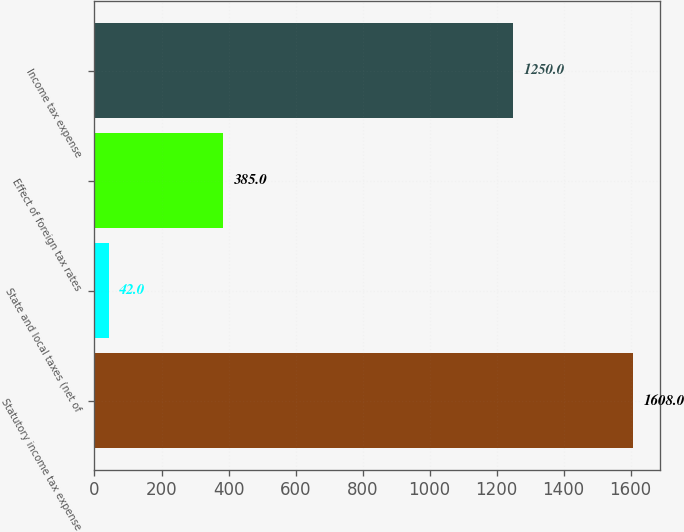Convert chart to OTSL. <chart><loc_0><loc_0><loc_500><loc_500><bar_chart><fcel>Statutory income tax expense<fcel>State and local taxes (net of<fcel>Effect of foreign tax rates<fcel>Income tax expense<nl><fcel>1608<fcel>42<fcel>385<fcel>1250<nl></chart> 